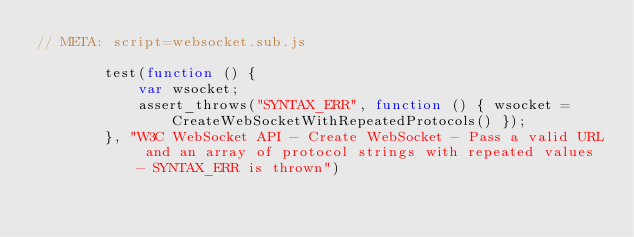Convert code to text. <code><loc_0><loc_0><loc_500><loc_500><_JavaScript_>// META: script=websocket.sub.js

        test(function () {
            var wsocket;
            assert_throws("SYNTAX_ERR", function () { wsocket = CreateWebSocketWithRepeatedProtocols() });
        }, "W3C WebSocket API - Create WebSocket - Pass a valid URL and an array of protocol strings with repeated values - SYNTAX_ERR is thrown")
</code> 